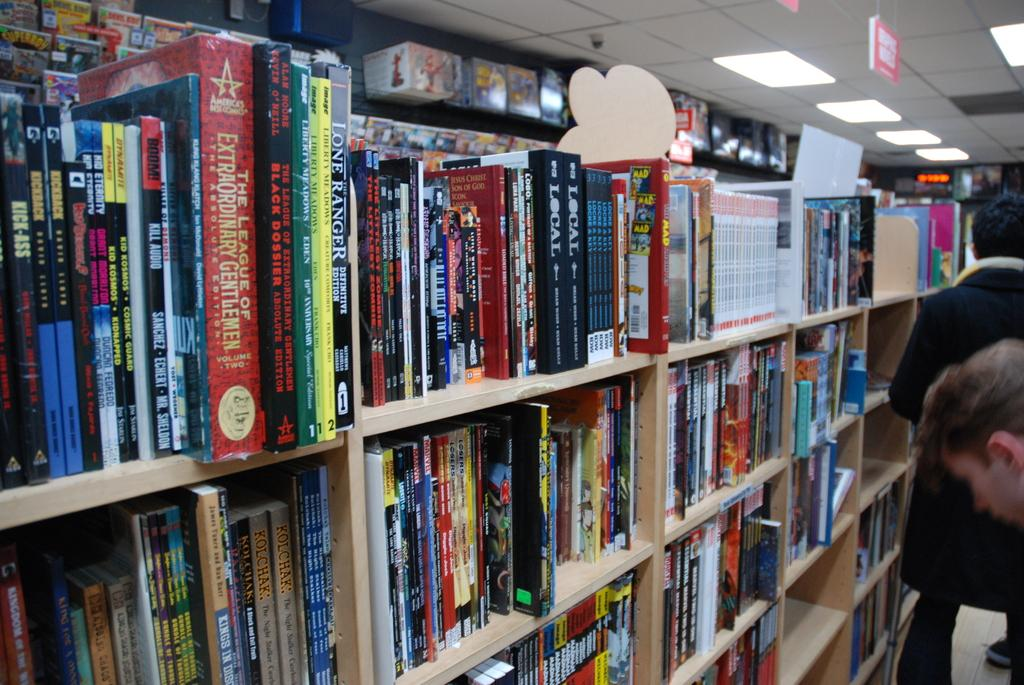<image>
Relay a brief, clear account of the picture shown. Multiple books line the shelves of a book store, among them is a copy of The League Of Extraordinary Gentlemen. 